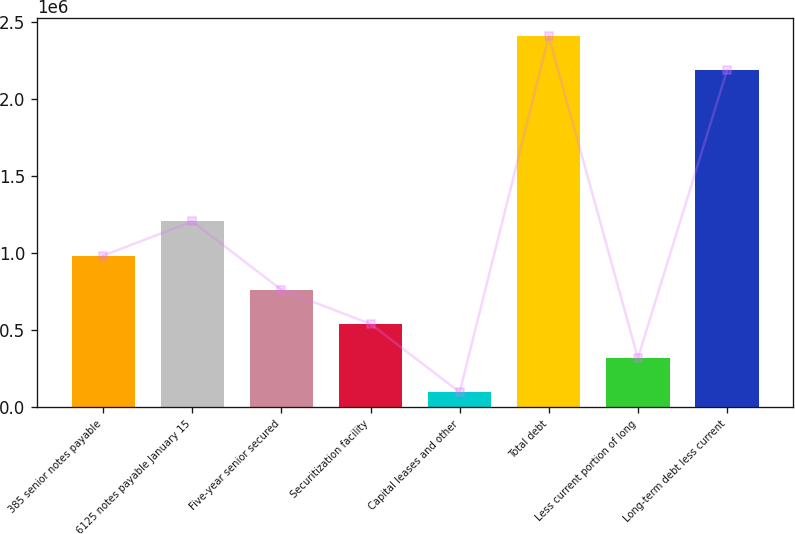<chart> <loc_0><loc_0><loc_500><loc_500><bar_chart><fcel>385 senior notes payable<fcel>6125 notes payable January 15<fcel>Five-year senior secured<fcel>Securitization facility<fcel>Capital leases and other<fcel>Total debt<fcel>Less current portion of long<fcel>Long-term debt less current<nl><fcel>982845<fcel>1.20456e+06<fcel>761134<fcel>539424<fcel>96003<fcel>2.4076e+06<fcel>317714<fcel>2.18589e+06<nl></chart> 